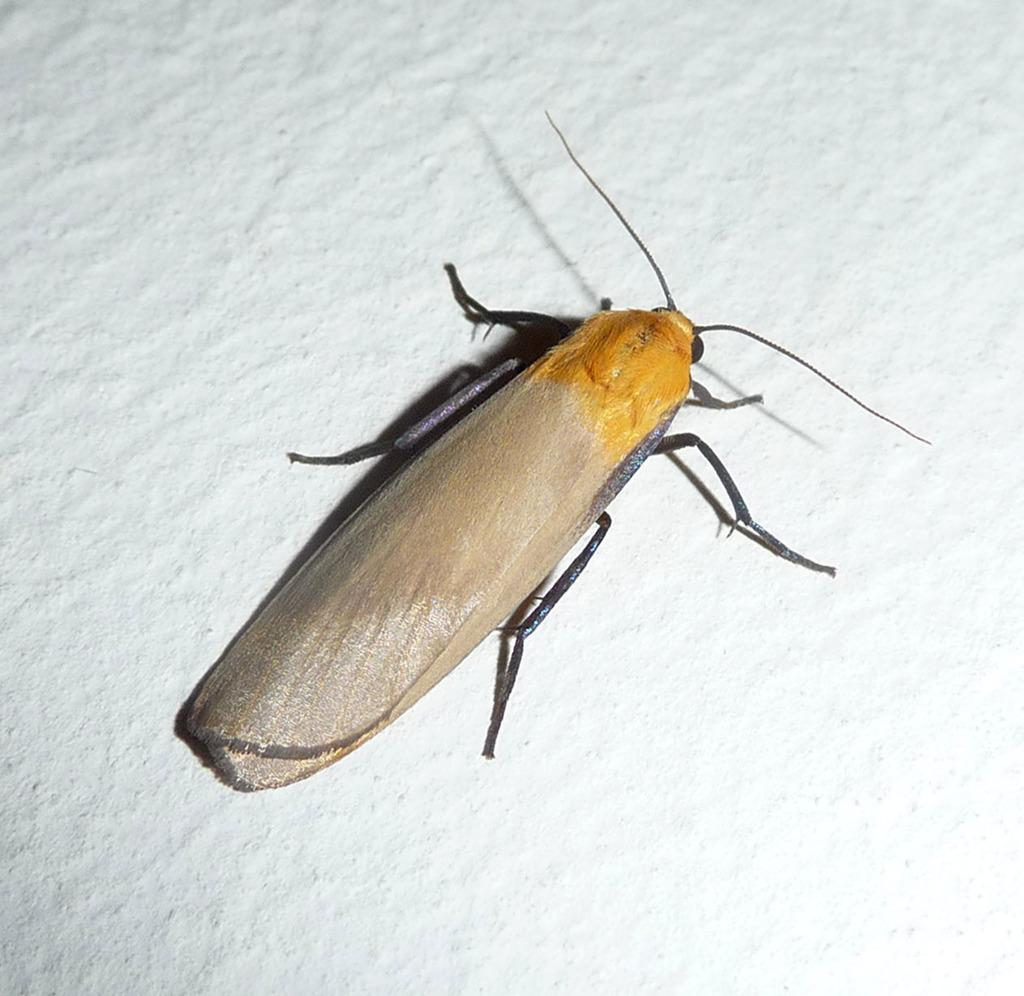What type of creature can be seen in the image? There is an insect in the image. What is the color of the surface where the insect is located? The insect is on a white-colored surface. Where is the harbor located in the image? There is no harbor present in the image; it only features an insect on a white-colored surface. What type of birth is depicted in the image? There is no birth depicted in the image; it only features an insect on a white-colored surface. 